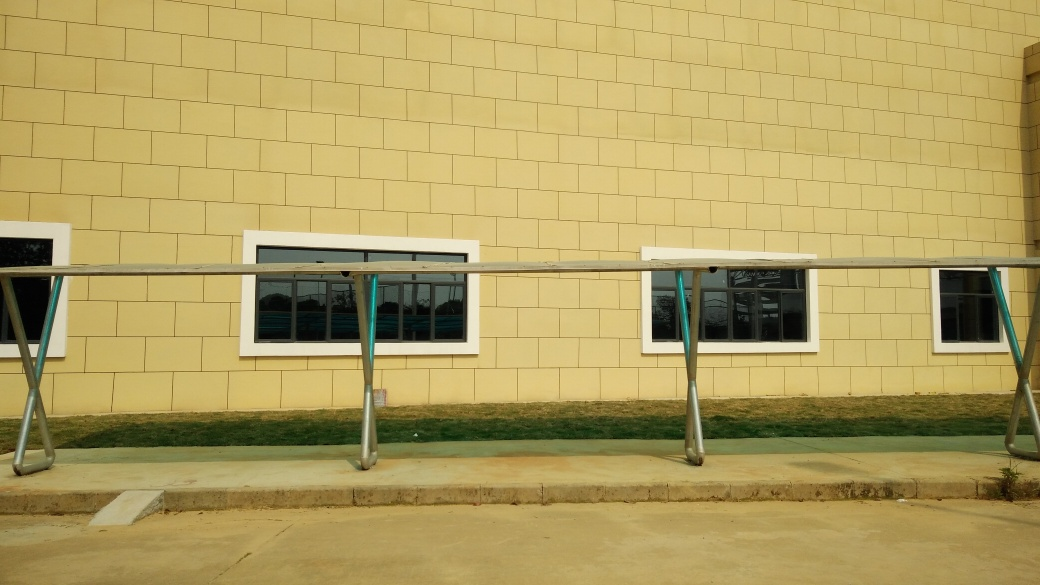What could be the function of this building, judging by its design and the visible surroundings? The building's design is quite plain and functional, suggesting it could be an office building or perhaps a facility belonging to an organization or an educational institution. There's not much that indicates commercial use. The well-maintained surrounding lawn and the orderly facade suggest the building is regularly maintained for a professional purpose. 